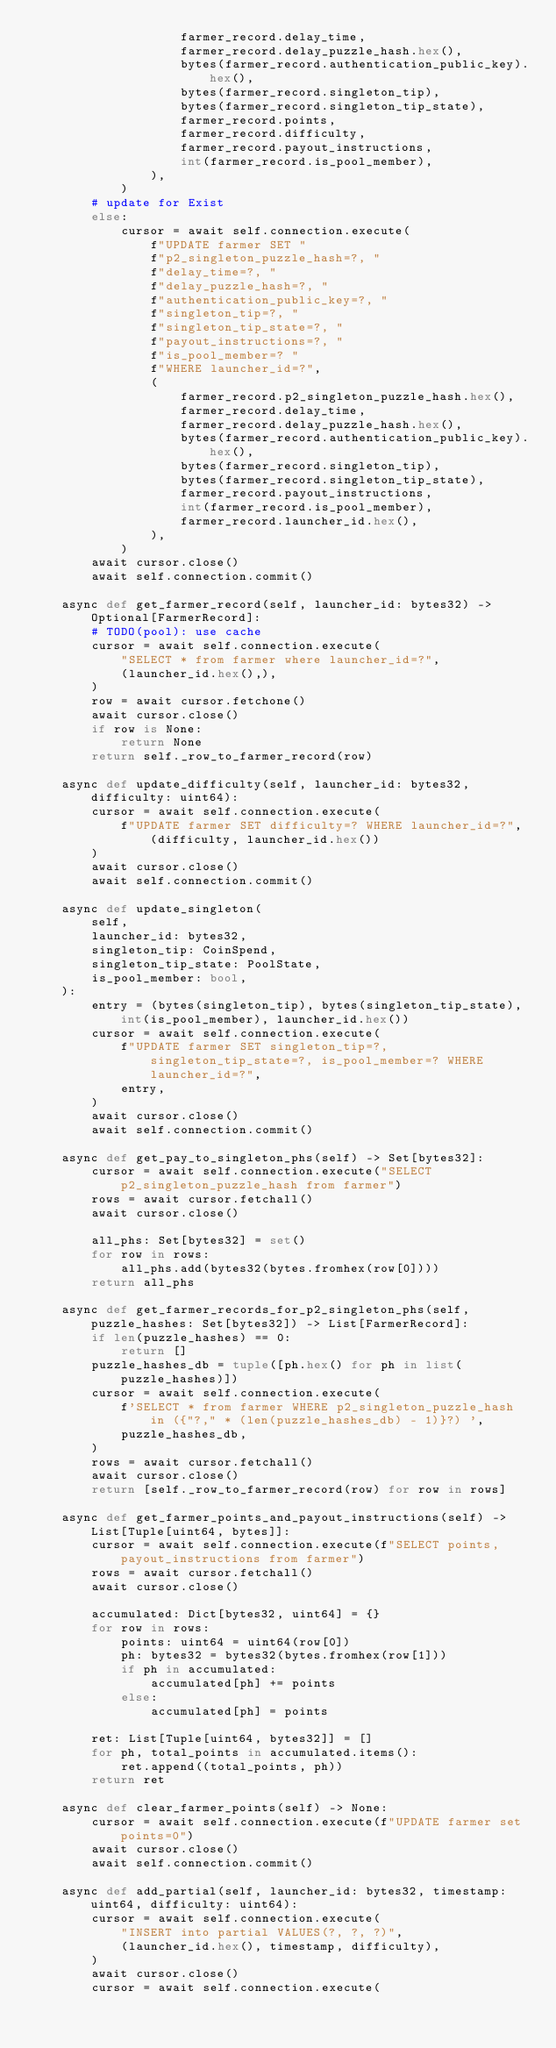<code> <loc_0><loc_0><loc_500><loc_500><_Python_>                    farmer_record.delay_time,
                    farmer_record.delay_puzzle_hash.hex(),
                    bytes(farmer_record.authentication_public_key).hex(),
                    bytes(farmer_record.singleton_tip),
                    bytes(farmer_record.singleton_tip_state),
                    farmer_record.points,
                    farmer_record.difficulty,
                    farmer_record.payout_instructions,
                    int(farmer_record.is_pool_member),
                ),
            )
        # update for Exist
        else:
            cursor = await self.connection.execute(
                f"UPDATE farmer SET "
                f"p2_singleton_puzzle_hash=?, "
                f"delay_time=?, "
                f"delay_puzzle_hash=?, "
                f"authentication_public_key=?, "
                f"singleton_tip=?, "
                f"singleton_tip_state=?, "
                f"payout_instructions=?, "
                f"is_pool_member=? "
                f"WHERE launcher_id=?",
                (
                    farmer_record.p2_singleton_puzzle_hash.hex(),
                    farmer_record.delay_time,
                    farmer_record.delay_puzzle_hash.hex(),
                    bytes(farmer_record.authentication_public_key).hex(),
                    bytes(farmer_record.singleton_tip),
                    bytes(farmer_record.singleton_tip_state),
                    farmer_record.payout_instructions,
                    int(farmer_record.is_pool_member),
                    farmer_record.launcher_id.hex(),
                ),
            )
        await cursor.close()
        await self.connection.commit()

    async def get_farmer_record(self, launcher_id: bytes32) -> Optional[FarmerRecord]:
        # TODO(pool): use cache
        cursor = await self.connection.execute(
            "SELECT * from farmer where launcher_id=?",
            (launcher_id.hex(),),
        )
        row = await cursor.fetchone()
        await cursor.close()
        if row is None:
            return None
        return self._row_to_farmer_record(row)

    async def update_difficulty(self, launcher_id: bytes32, difficulty: uint64):
        cursor = await self.connection.execute(
            f"UPDATE farmer SET difficulty=? WHERE launcher_id=?", (difficulty, launcher_id.hex())
        )
        await cursor.close()
        await self.connection.commit()

    async def update_singleton(
        self,
        launcher_id: bytes32,
        singleton_tip: CoinSpend,
        singleton_tip_state: PoolState,
        is_pool_member: bool,
    ):
        entry = (bytes(singleton_tip), bytes(singleton_tip_state), int(is_pool_member), launcher_id.hex())
        cursor = await self.connection.execute(
            f"UPDATE farmer SET singleton_tip=?, singleton_tip_state=?, is_pool_member=? WHERE launcher_id=?",
            entry,
        )
        await cursor.close()
        await self.connection.commit()

    async def get_pay_to_singleton_phs(self) -> Set[bytes32]:
        cursor = await self.connection.execute("SELECT p2_singleton_puzzle_hash from farmer")
        rows = await cursor.fetchall()
        await cursor.close()

        all_phs: Set[bytes32] = set()
        for row in rows:
            all_phs.add(bytes32(bytes.fromhex(row[0])))
        return all_phs

    async def get_farmer_records_for_p2_singleton_phs(self, puzzle_hashes: Set[bytes32]) -> List[FarmerRecord]:
        if len(puzzle_hashes) == 0:
            return []
        puzzle_hashes_db = tuple([ph.hex() for ph in list(puzzle_hashes)])
        cursor = await self.connection.execute(
            f'SELECT * from farmer WHERE p2_singleton_puzzle_hash in ({"?," * (len(puzzle_hashes_db) - 1)}?) ',
            puzzle_hashes_db,
        )
        rows = await cursor.fetchall()
        await cursor.close()
        return [self._row_to_farmer_record(row) for row in rows]

    async def get_farmer_points_and_payout_instructions(self) -> List[Tuple[uint64, bytes]]:
        cursor = await self.connection.execute(f"SELECT points, payout_instructions from farmer")
        rows = await cursor.fetchall()
        await cursor.close()

        accumulated: Dict[bytes32, uint64] = {}
        for row in rows:
            points: uint64 = uint64(row[0])
            ph: bytes32 = bytes32(bytes.fromhex(row[1]))
            if ph in accumulated:
                accumulated[ph] += points
            else:
                accumulated[ph] = points

        ret: List[Tuple[uint64, bytes32]] = []
        for ph, total_points in accumulated.items():
            ret.append((total_points, ph))
        return ret

    async def clear_farmer_points(self) -> None:
        cursor = await self.connection.execute(f"UPDATE farmer set points=0")
        await cursor.close()
        await self.connection.commit()

    async def add_partial(self, launcher_id: bytes32, timestamp: uint64, difficulty: uint64):
        cursor = await self.connection.execute(
            "INSERT into partial VALUES(?, ?, ?)",
            (launcher_id.hex(), timestamp, difficulty),
        )
        await cursor.close()
        cursor = await self.connection.execute(</code> 